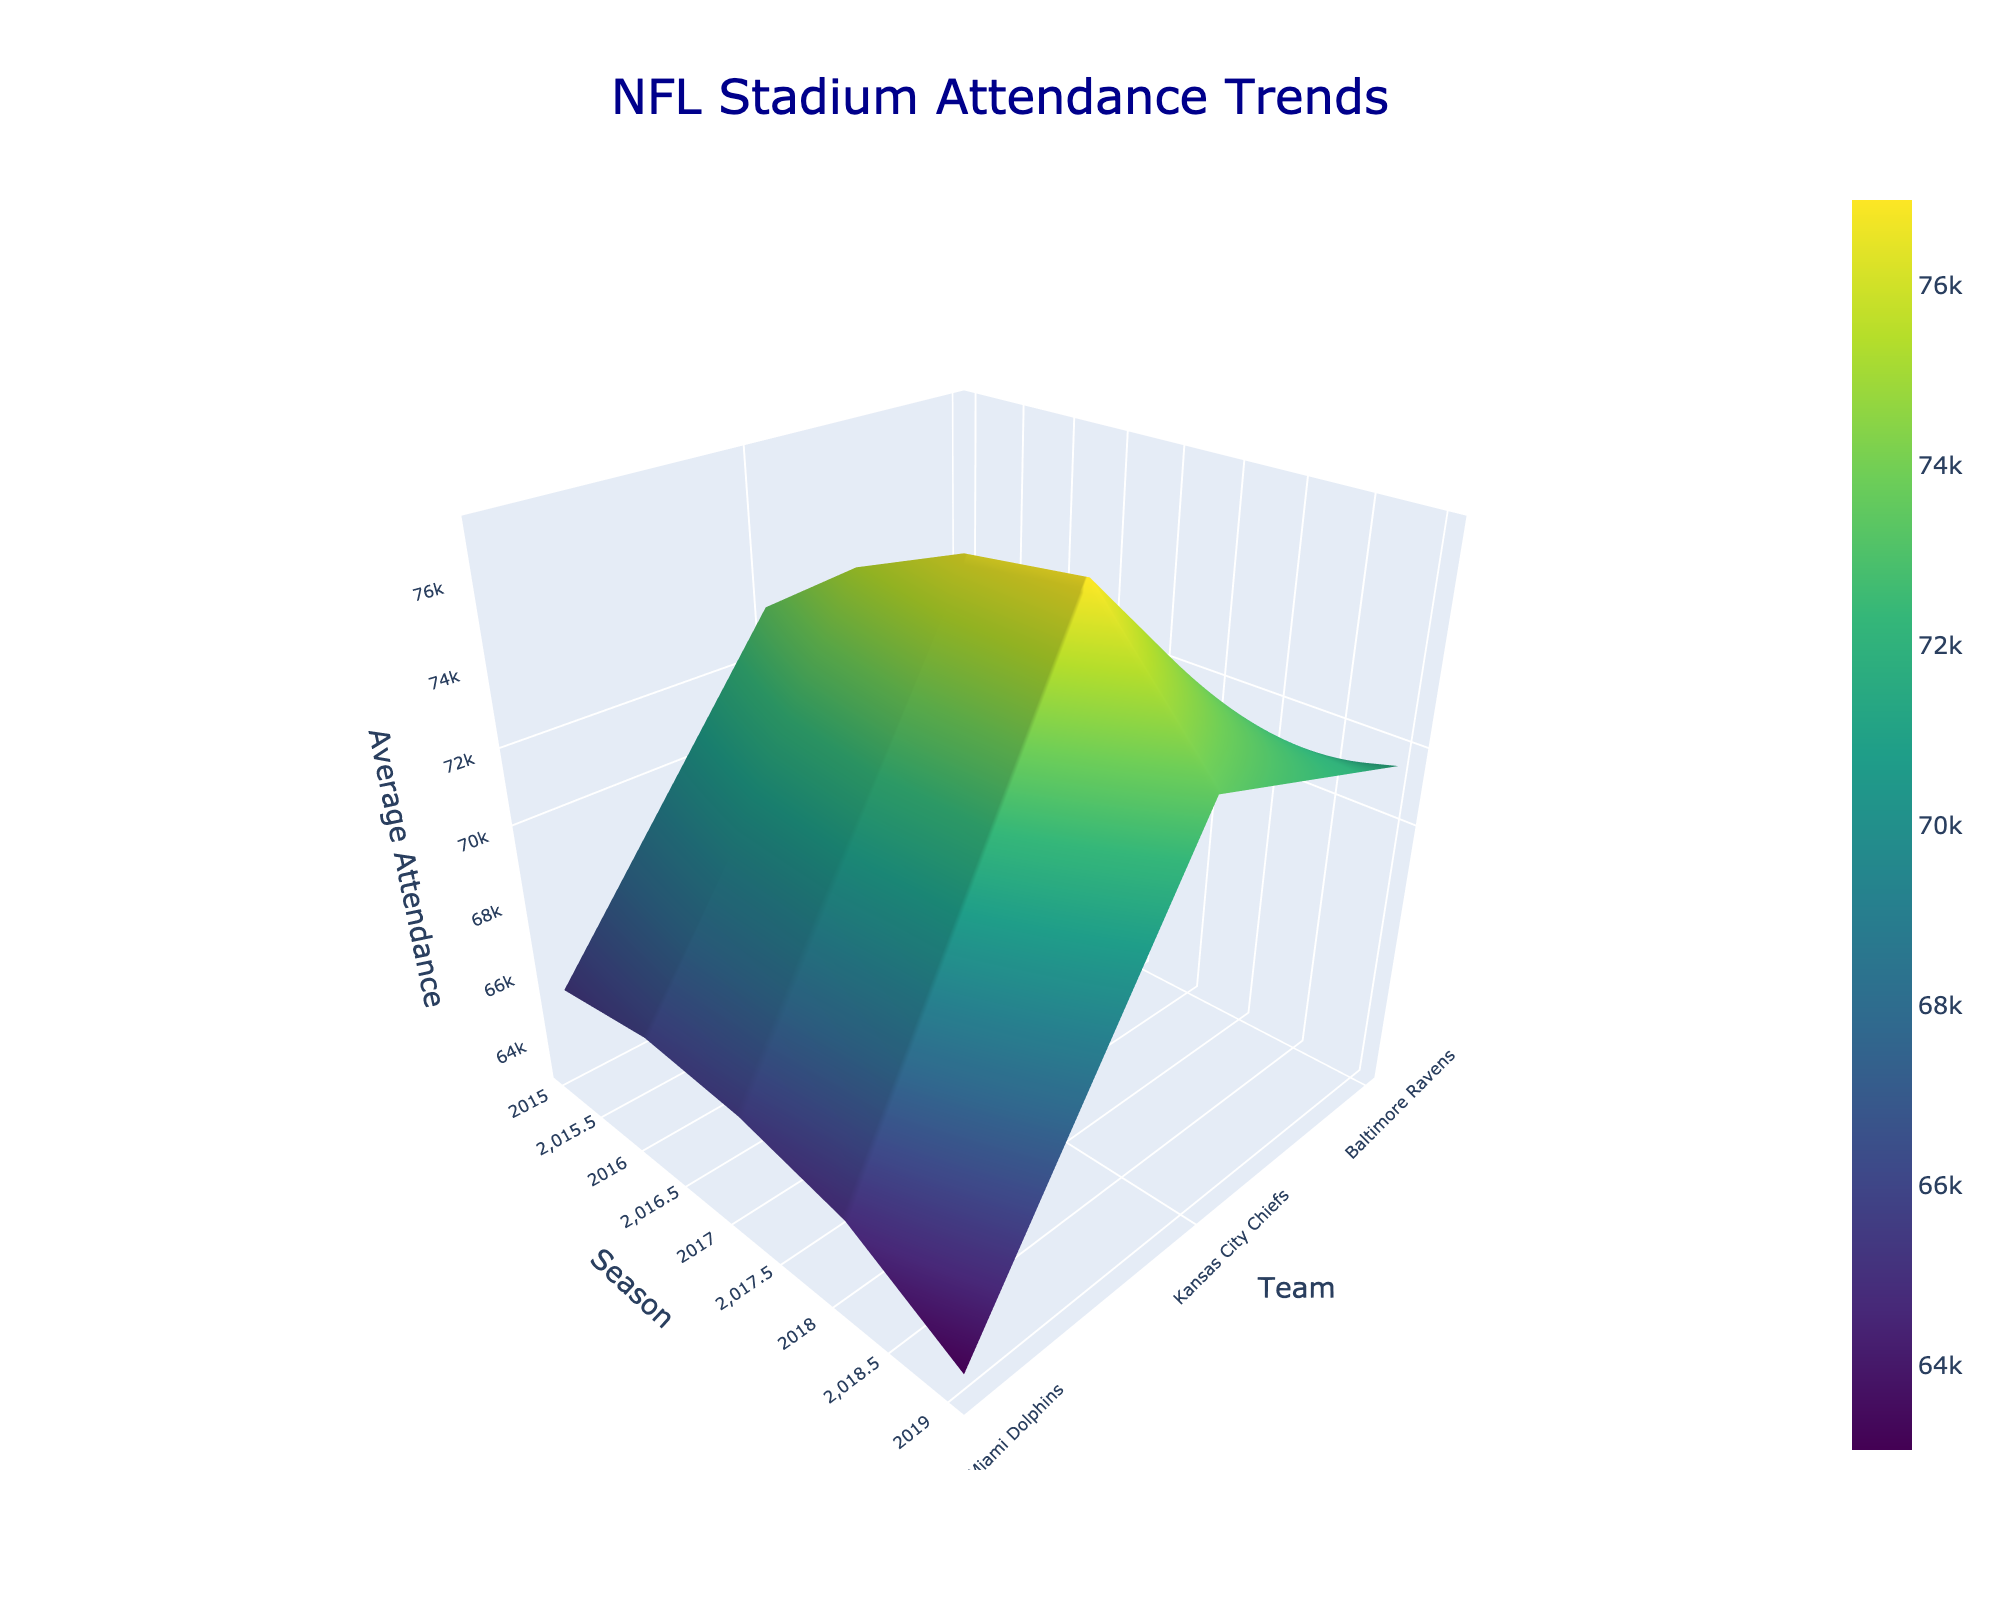What is the title of the figure? The title can be found at the top of the figure. It is usually in a larger and bolder font compared to other text.
Answer: NFL Stadium Attendance Trends Which teams are represented in the figure? The teams are labeled along one of the axes, and these are the unique teams whose attendance data is shown over multiple seasons.
Answer: Baltimore Ravens, Kansas City Chiefs, Miami Dolphins How does the average attendance for the Kansas City Chiefs in 2017 compare to that in 2018? Locate the data points for the Kansas City Chiefs for both 2017 and 2018 on the surface plot, then compare their average attendance values along the z-axis.
Answer: 2018 is higher than 2017 What axis represents the different seasons in the figure? Look at the labels on the three axes; one of them should have values corresponding to different season years given in the dataset.
Answer: Y-axis Which team had the highest average attendance in 2019? Examine the data points along the 2019 season (y-axis) and compare the z-axis values (average attendance) for all teams.
Answer: Baltimore Ravens How does the average attendance change for the Miami Dolphins from 2015 to 2019? Find the data points corresponding to the Miami Dolphins and trace the changes in their average attendance from 2015 through to 2019 by observing the surface plot.
Answer: Decreases Looking at the plot, which team shows a consistent increase in average attendance over the seasons? Follow the trend along the z-axis for each team across all seasons. The team with a generally upward slope indicates consistent increase.
Answer: Kansas City Chiefs Which season had the most variability in attendance between the teams? Assess the peaks and troughs for a given y-axis (season) and determine which season shows the largest difference in average attendance values among the teams.
Answer: 2018 Between the Baltimore Ravens and Miami Dolphins, which team has the higher average ticket price in 2017? Although the plot focuses on attendance, check the values in the dataset for 2017 to find the average ticket prices for both teams and compare them.
Answer: Miami Dolphins What is the overall trend in attendance for the Baltimore Ravens across the seasons? Trace the Baltimore Ravens' data points from 2015 to 2019, observing whether the z-axis values (average attendance) increase, decrease, or remain stable.
Answer: Slightly increasing 